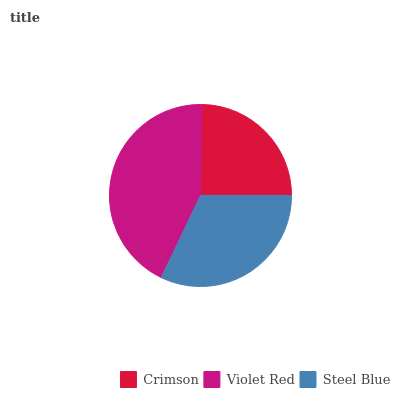Is Crimson the minimum?
Answer yes or no. Yes. Is Violet Red the maximum?
Answer yes or no. Yes. Is Steel Blue the minimum?
Answer yes or no. No. Is Steel Blue the maximum?
Answer yes or no. No. Is Violet Red greater than Steel Blue?
Answer yes or no. Yes. Is Steel Blue less than Violet Red?
Answer yes or no. Yes. Is Steel Blue greater than Violet Red?
Answer yes or no. No. Is Violet Red less than Steel Blue?
Answer yes or no. No. Is Steel Blue the high median?
Answer yes or no. Yes. Is Steel Blue the low median?
Answer yes or no. Yes. Is Crimson the high median?
Answer yes or no. No. Is Crimson the low median?
Answer yes or no. No. 